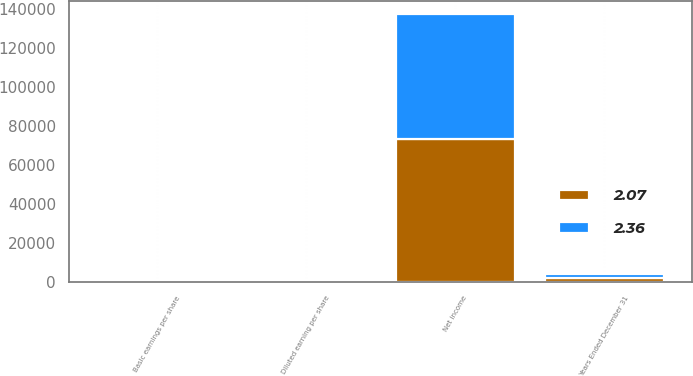Convert chart to OTSL. <chart><loc_0><loc_0><loc_500><loc_500><stacked_bar_chart><ecel><fcel>Years Ended December 31<fcel>Net income<fcel>Basic earnings per share<fcel>Diluted earning per share<nl><fcel>2.36<fcel>2001<fcel>63983<fcel>2.09<fcel>2.07<nl><fcel>2.07<fcel>2000<fcel>73463<fcel>2.39<fcel>2.36<nl></chart> 